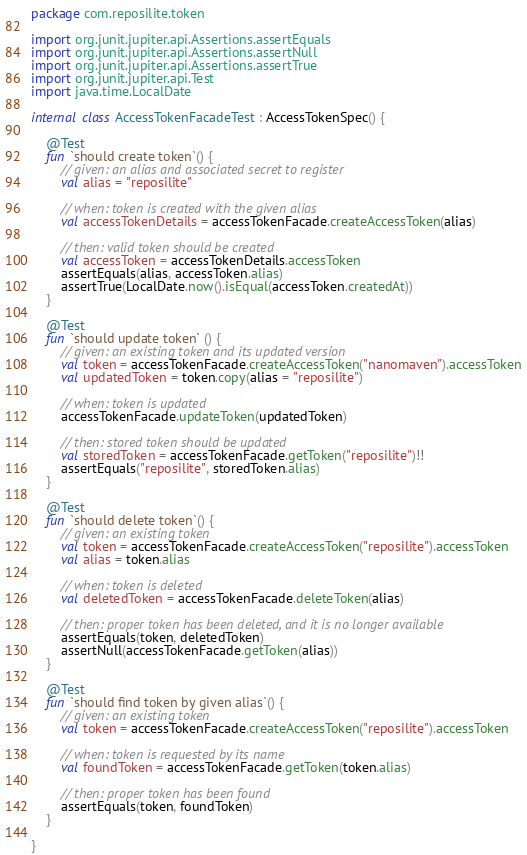<code> <loc_0><loc_0><loc_500><loc_500><_Kotlin_>package com.reposilite.token

import org.junit.jupiter.api.Assertions.assertEquals
import org.junit.jupiter.api.Assertions.assertNull
import org.junit.jupiter.api.Assertions.assertTrue
import org.junit.jupiter.api.Test
import java.time.LocalDate

internal class AccessTokenFacadeTest : AccessTokenSpec() {

    @Test
    fun `should create token`() {
        // given: an alias and associated secret to register
        val alias = "reposilite"

        // when: token is created with the given alias
        val accessTokenDetails = accessTokenFacade.createAccessToken(alias)

        // then: valid token should be created
        val accessToken = accessTokenDetails.accessToken
        assertEquals(alias, accessToken.alias)
        assertTrue(LocalDate.now().isEqual(accessToken.createdAt))
    }

    @Test
    fun `should update token` () {
        // given: an existing token and its updated version
        val token = accessTokenFacade.createAccessToken("nanomaven").accessToken
        val updatedToken = token.copy(alias = "reposilite")

        // when: token is updated
        accessTokenFacade.updateToken(updatedToken)

        // then: stored token should be updated
        val storedToken = accessTokenFacade.getToken("reposilite")!!
        assertEquals("reposilite", storedToken.alias)
    }

    @Test
    fun `should delete token`() {
        // given: an existing token
        val token = accessTokenFacade.createAccessToken("reposilite").accessToken
        val alias = token.alias

        // when: token is deleted
        val deletedToken = accessTokenFacade.deleteToken(alias)

        // then: proper token has been deleted, and it is no longer available
        assertEquals(token, deletedToken)
        assertNull(accessTokenFacade.getToken(alias))
    }

    @Test
    fun `should find token by given alias`() {
        // given: an existing token
        val token = accessTokenFacade.createAccessToken("reposilite").accessToken

        // when: token is requested by its name
        val foundToken = accessTokenFacade.getToken(token.alias)

        // then: proper token has been found
        assertEquals(token, foundToken)
    }

}</code> 